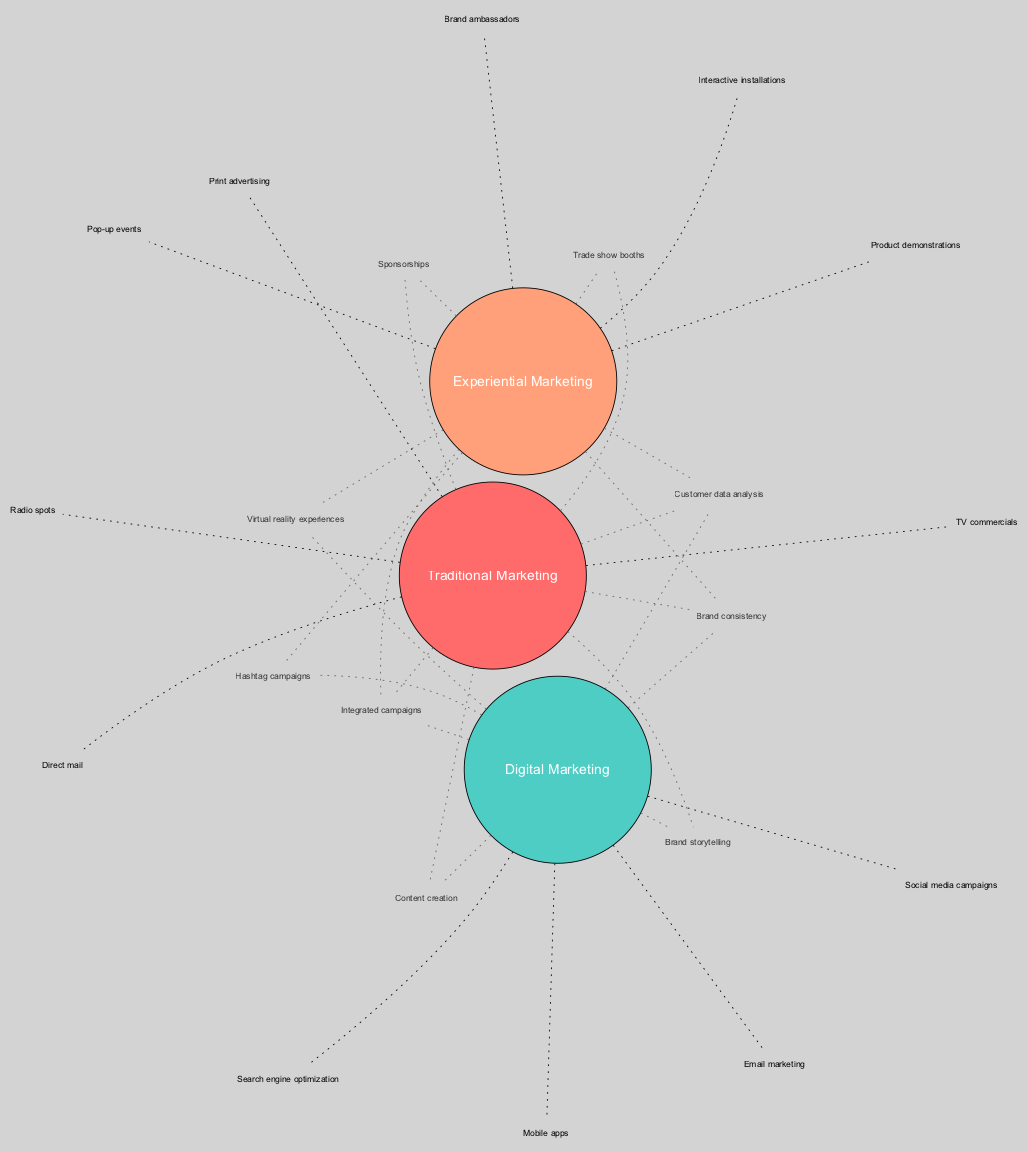What are the elements of Traditional Marketing? The elements under the "Traditional Marketing" set include "Print advertising," "TV commercials," "Radio spots," and "Direct mail." These are listed directly under the traditional marketing circle in the diagram.
Answer: Print advertising, TV commercials, Radio spots, Direct mail How many elements are in Digital Marketing? The "Digital Marketing" set contains four elements: "Social media campaigns," "Search engine optimization," "Email marketing," and "Mobile apps." The diagram shows each of these as distinct elements associated with the digital marketing circle.
Answer: 4 What overlapping elements exist between Traditional and Digital Marketing? The intersection of "Traditional Marketing" and "Digital Marketing" includes "Content creation" and "Brand storytelling." This is indicated in the area where the two circles overlap in the diagram.
Answer: Content creation, Brand storytelling Which marketing strategy includes Brand ambassadors? "Brand ambassadors" are part of the "Experiential Marketing" set as shown in that section of the diagram. This is specifically illustrated in the experiential marketing circle.
Answer: Experiential Marketing How many intersections are there between the three marketing types? There are four defined intersections in total: two intersections between two sets and one intersection that includes all three sets. The document specifies distinct elements for each intersection, which helps calculate the total.
Answer: 4 What does the intersection of Digital and Experiential Marketing contain? The intersection of "Digital Marketing" and "Experiential Marketing" features "Virtual reality experiences" and "Hashtag campaigns," explicitly mentioned in the section where these two circles overlap.
Answer: Virtual reality experiences, Hashtag campaigns Which marketing strategy has the most unique elements? "Traditional Marketing" and "Experiential Marketing" each have unique elements that do not overlap with the others, but "Digital Marketing" has elements that combine with others most often, so based on uniqueness, "Experiential Marketing" may have fewer unique elements. However, "Digital Marketing" combines more elements with the others in overlaps.
Answer: Experiential Marketing How many total marketing strategies are compared? The diagram compares three distinct marketing strategies: Traditional, Digital, and Experiential Marketing, as evidenced by the three sets displayed within the diagram.
Answer: 3 What are the elements at the center intersection of all three marketing strategies? The center intersection that connects "Traditional Marketing," "Digital Marketing," and "Experiential Marketing" includes "Integrated campaigns," "Customer data analysis," and "Brand consistency." All three elements highlight synergy across all marketing strategies in this area.
Answer: Integrated campaigns, Customer data analysis, Brand consistency 